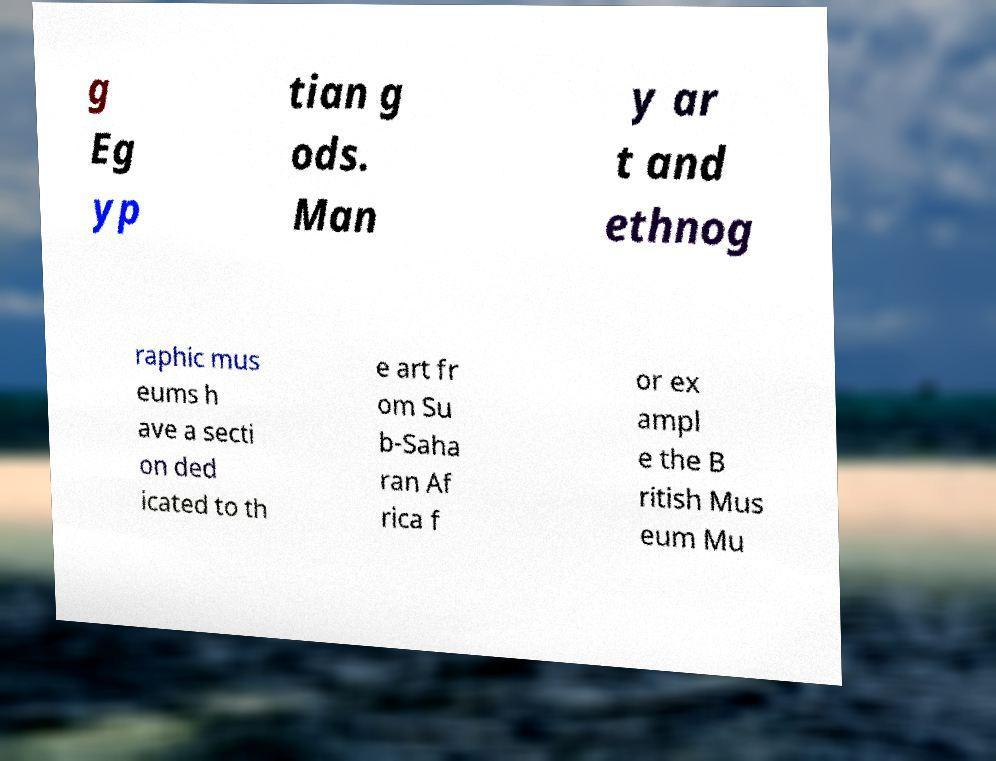Can you accurately transcribe the text from the provided image for me? g Eg yp tian g ods. Man y ar t and ethnog raphic mus eums h ave a secti on ded icated to th e art fr om Su b-Saha ran Af rica f or ex ampl e the B ritish Mus eum Mu 